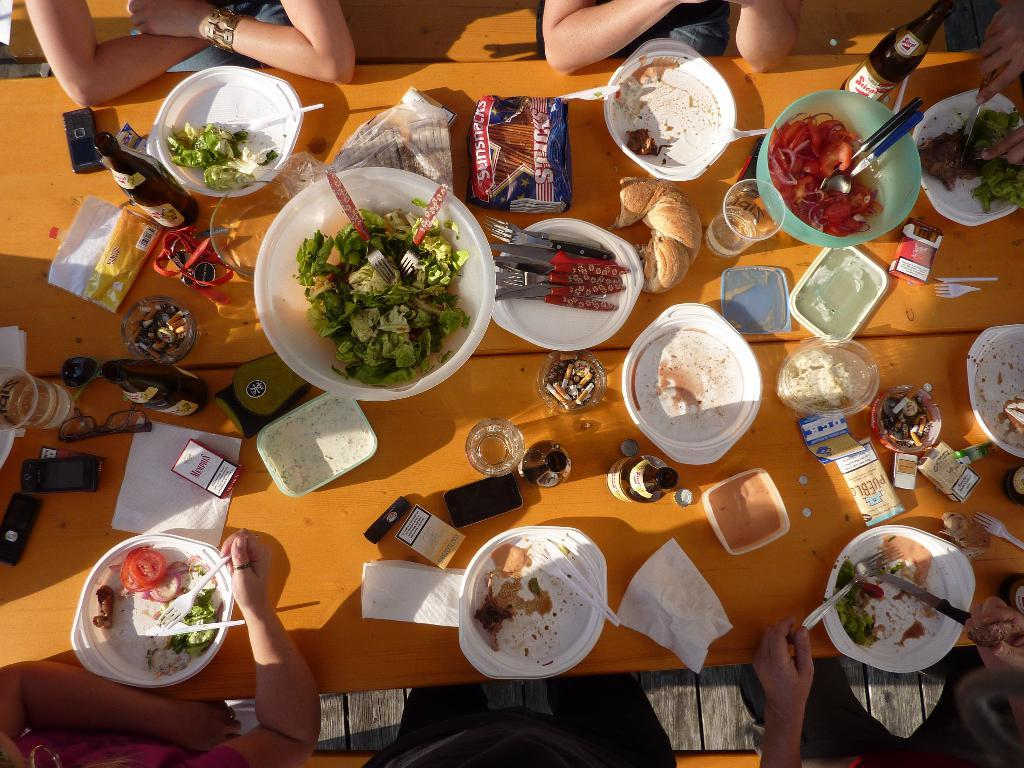What is in the bowl that is visible in the image? There are food items in a bowl in the image. What else can be seen in the image besides the bowl? There are bottles and a fork visible in the image. What might be used for eating the food items in the bowl? The fork in the image can be used for eating the food items. What is the setting in which the food items are being consumed? People are sitting around a table in the image. What type of cloud is visible in the image? There are no clouds visible in the image; it is an indoor scene with people sitting around a table. 